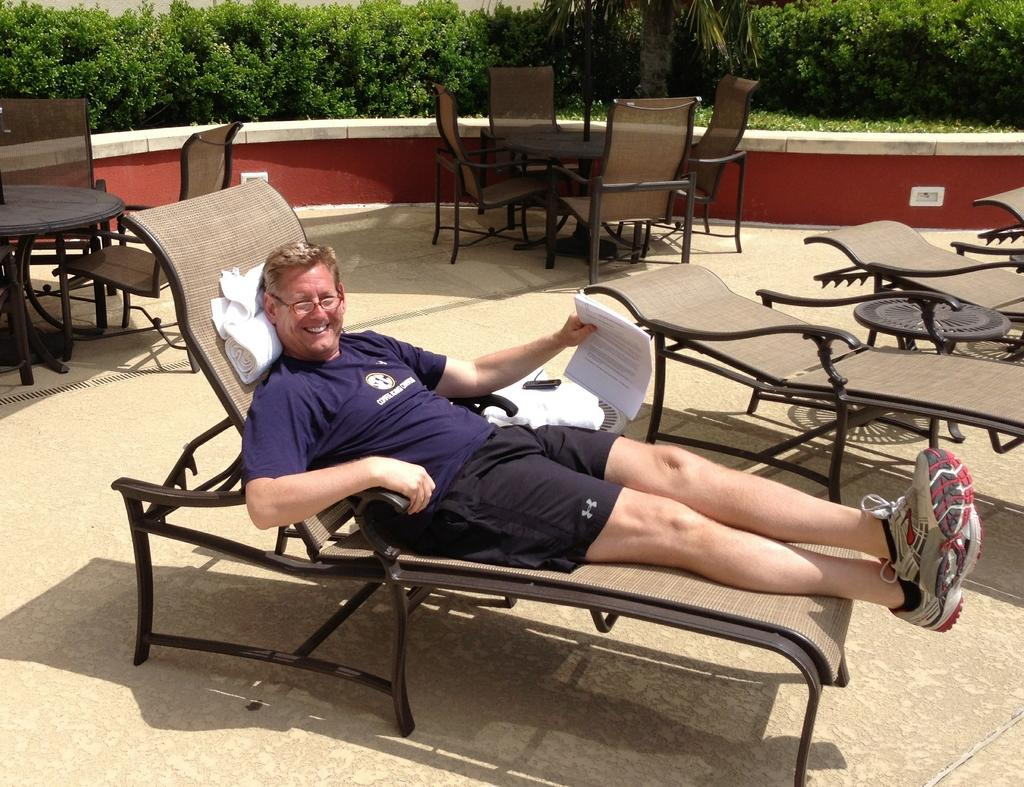Who is present in the image? There is a man in the image. What is the man holding in the image? The man is holding a paper. What is the man's position in the image? The man is lying on a chair. What type of vegetation can be seen in the image? There are plants visible in the image. How many chairs are present in the image? There are multiple chairs in the image. What type of furniture is also visible in the image? There are tables in the image. What type of cord is being used to fight in the image? There is no cord or fighting present in the image. 